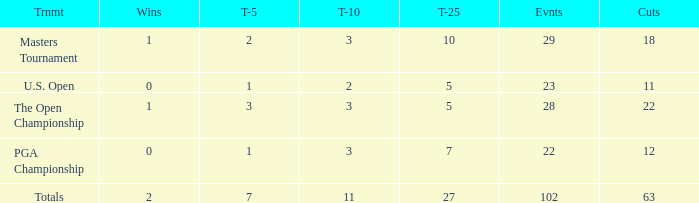How many vuts made for a player with 2 wins and under 7 top 5s? None. 